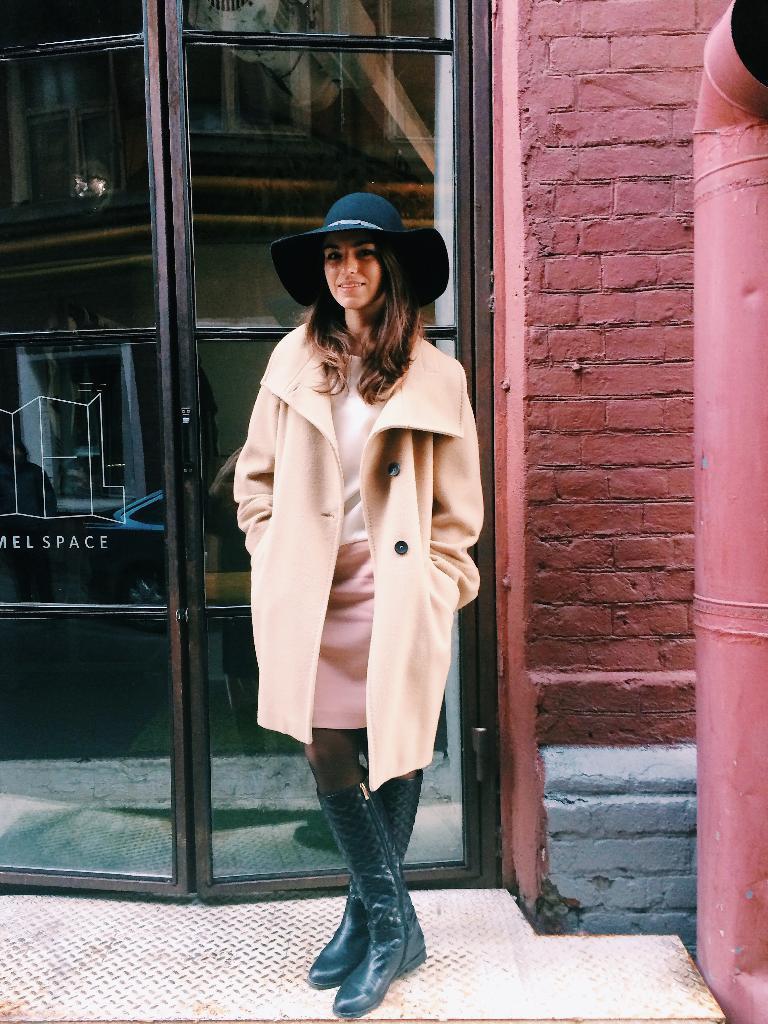Could you give a brief overview of what you see in this image? In the picture I can see a woman standing on the floor and there is a smile on her face. She is wearing the clothes and there is a black color cap on her head. I can see the glass door on the left side. I can see the brick wall and ventilation pipe on the right side. 